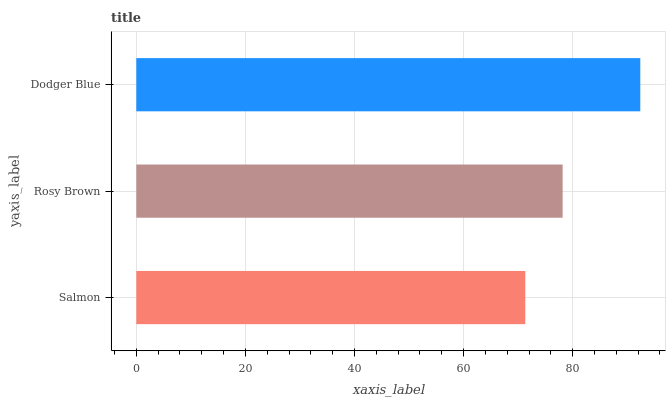Is Salmon the minimum?
Answer yes or no. Yes. Is Dodger Blue the maximum?
Answer yes or no. Yes. Is Rosy Brown the minimum?
Answer yes or no. No. Is Rosy Brown the maximum?
Answer yes or no. No. Is Rosy Brown greater than Salmon?
Answer yes or no. Yes. Is Salmon less than Rosy Brown?
Answer yes or no. Yes. Is Salmon greater than Rosy Brown?
Answer yes or no. No. Is Rosy Brown less than Salmon?
Answer yes or no. No. Is Rosy Brown the high median?
Answer yes or no. Yes. Is Rosy Brown the low median?
Answer yes or no. Yes. Is Salmon the high median?
Answer yes or no. No. Is Dodger Blue the low median?
Answer yes or no. No. 